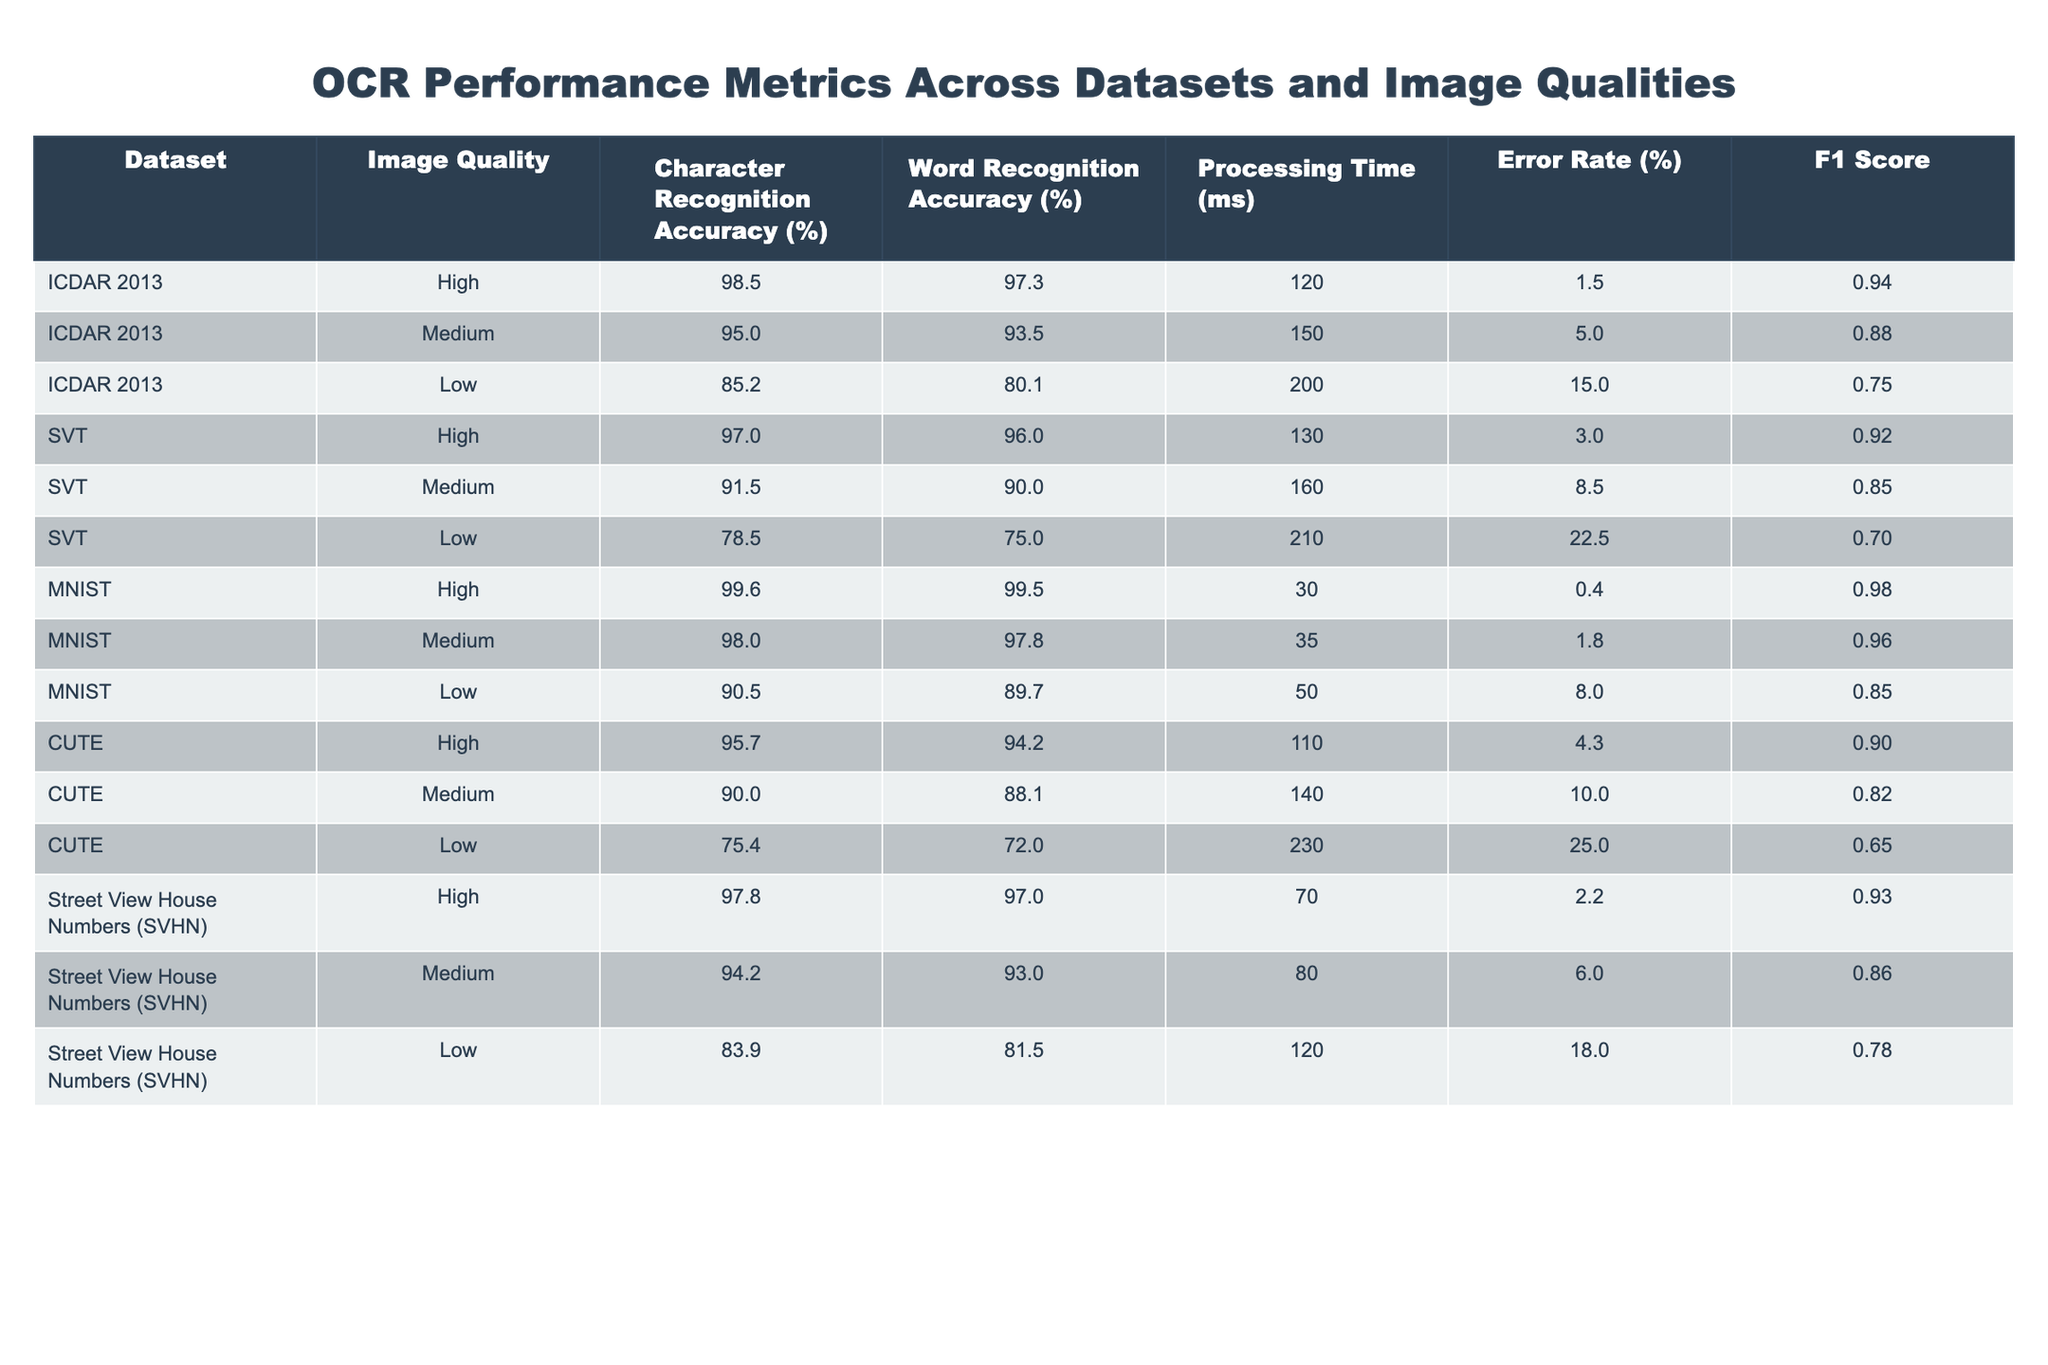What is the Character Recognition Accuracy for the ICDAR 2013 dataset at High image quality? The table indicates that the Character Recognition Accuracy for ICDAR 2013 at High image quality is 98.5%.
Answer: 98.5% What is the Word Recognition Accuracy for the MNIST dataset at Low image quality? According to the table, the Word Recognition Accuracy for MNIST at Low image quality is 89.7%.
Answer: 89.7% Which dataset exhibits the lowest Character Recognition Accuracy at Medium image quality? Comparing the Character Recognition Accuracy at Medium image quality, ICDAR 2013 has 95.0%, SVT has 91.5%, MNIST has 98.0%, CUTE has 90.0%, and SVHN has 94.2%. The lowest is from SVT with 91.5%.
Answer: SVT What is the average Processing Time for the High image quality settings across all datasets? To find the average, sum the Processing Times for High image quality (120 + 130 + 30 + 110 + 70) = 560 ms for 5 datasets, which gives an average of 560/5 = 112 ms.
Answer: 112 What is the Error Rate for the CUTE dataset at Low image quality? The table displays that the Error Rate for the CUTE dataset at Low image quality is 25.0%.
Answer: 25.0% Is the F1 Score for the SVT dataset lower at Low image quality compared to the ICDAR 2013 dataset at Low image quality? The F1 Score for SVT at Low is 0.70, while ICDAR 2013 at Low has 0.75. Since 0.70 is less than 0.75, it is true that SVT has a lower F1 Score at Low image quality compared to ICDAR 2013.
Answer: Yes Which dataset shows the highest Error Rate overall? By checking the Error Rates, ICDAR 2013 at Low image quality has 15.0%, SVT at Low has 22.5%, MNIST at Low has 8.0%, CUTE at Low has 25.0%, and SVHN at Low has 18.0%. The highest Error Rate is 25.0% from CUTE.
Answer: CUTE What is the difference in Character Recognition Accuracy between the High and Low image qualities for the SVHN dataset? The Character Recognition Accuracy for SVHN at High is 97.8% and at Low is 83.9%. The difference is 97.8 - 83.9 = 13.9%.
Answer: 13.9 What is the F1 Score for the best-performing dataset at Medium image quality? The F1 Scores at Medium for each dataset are ICDAR 2013 (0.88), SVT (0.85), MNIST (0.96), CUTE (0.82), SVHN (0.86). The highest F1 Score at Medium is 0.96 for MNIST.
Answer: 0.96 How does the Processing Time at High image quality for MNIST compare to that of CUTE? The Processing Time for MNIST at High image quality is 30 ms, while for CUTE it is 110 ms. The difference is 110 - 30 = 80 ms, indicating MNIST is processed significantly faster.
Answer: 80 ms Is the Word Recognition Accuracy higher for CUTE at High image quality than for SVT at Medium image quality? CUTE at High image quality has 94.2%, while SVT at Medium has 90.0%. Since 94.2% is greater than 90.0%, this statement is true.
Answer: Yes 